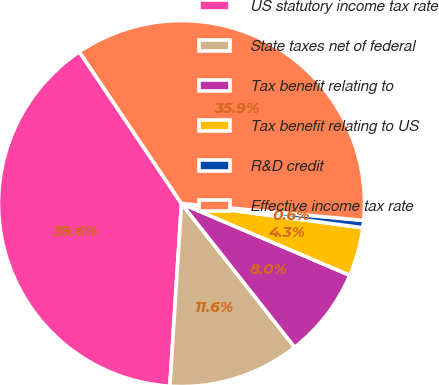<chart> <loc_0><loc_0><loc_500><loc_500><pie_chart><fcel>US statutory income tax rate<fcel>State taxes net of federal<fcel>Tax benefit relating to<fcel>Tax benefit relating to US<fcel>R&D credit<fcel>Effective income tax rate<nl><fcel>39.56%<fcel>11.63%<fcel>7.97%<fcel>4.3%<fcel>0.64%<fcel>35.9%<nl></chart> 